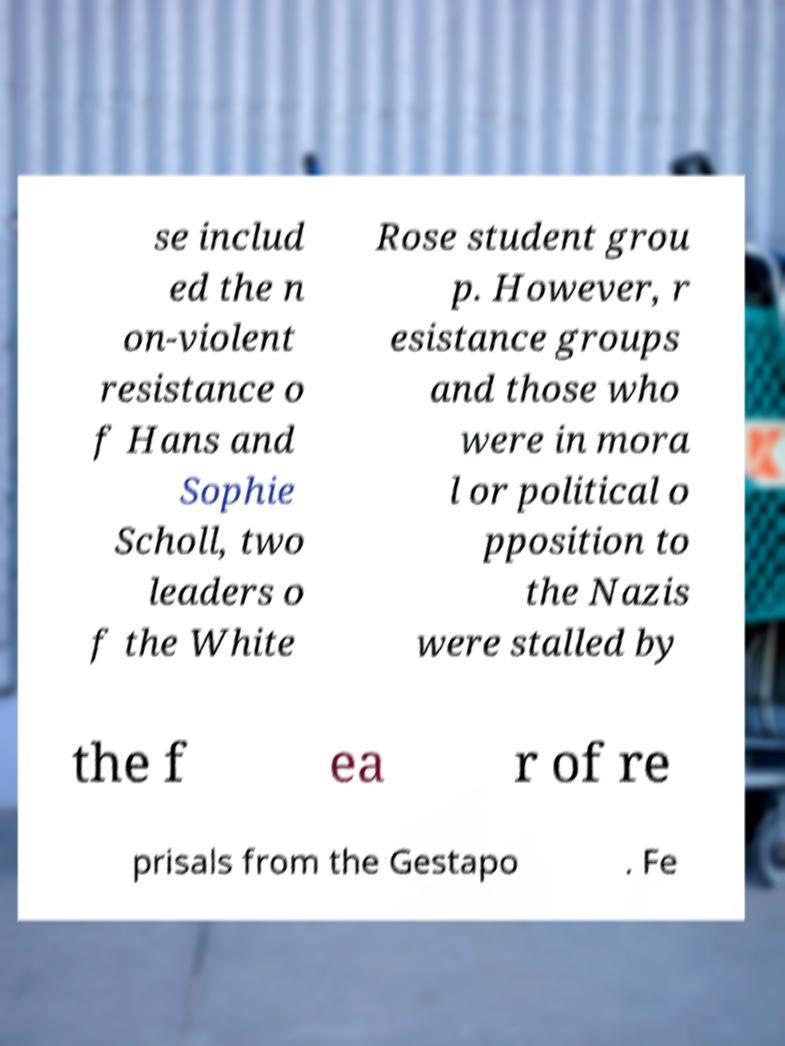Could you extract and type out the text from this image? se includ ed the n on-violent resistance o f Hans and Sophie Scholl, two leaders o f the White Rose student grou p. However, r esistance groups and those who were in mora l or political o pposition to the Nazis were stalled by the f ea r of re prisals from the Gestapo . Fe 